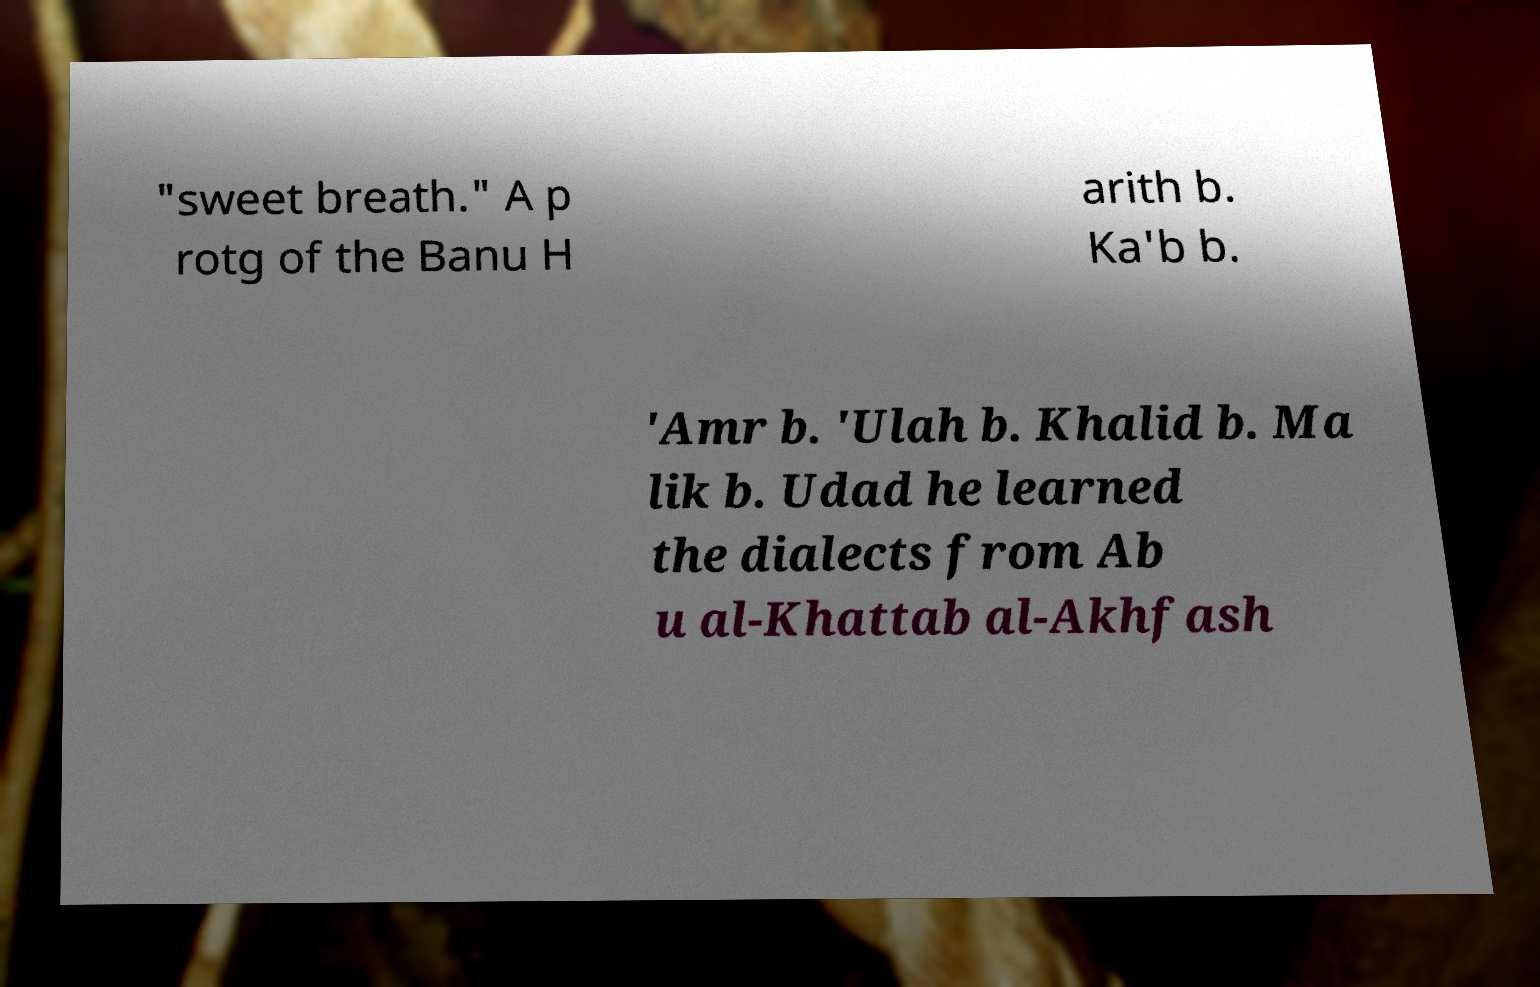Could you assist in decoding the text presented in this image and type it out clearly? "sweet breath." A p rotg of the Banu H arith b. Ka'b b. 'Amr b. 'Ulah b. Khalid b. Ma lik b. Udad he learned the dialects from Ab u al-Khattab al-Akhfash 